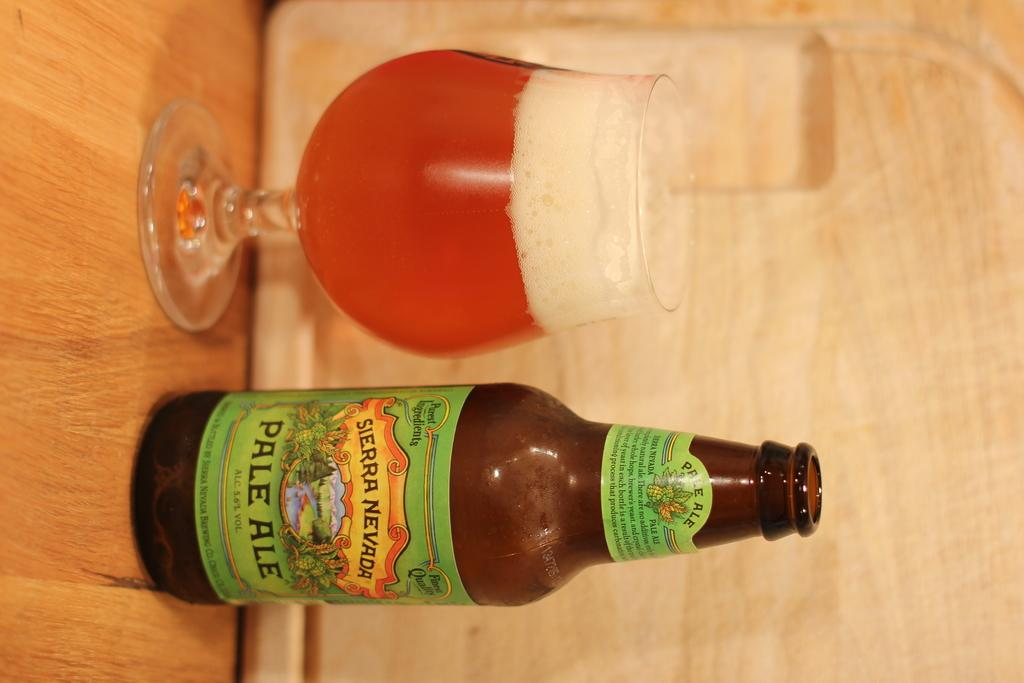<image>
Offer a succinct explanation of the picture presented. A bottle of Sierra Nevada Pale Ale next to a glass of beer. 